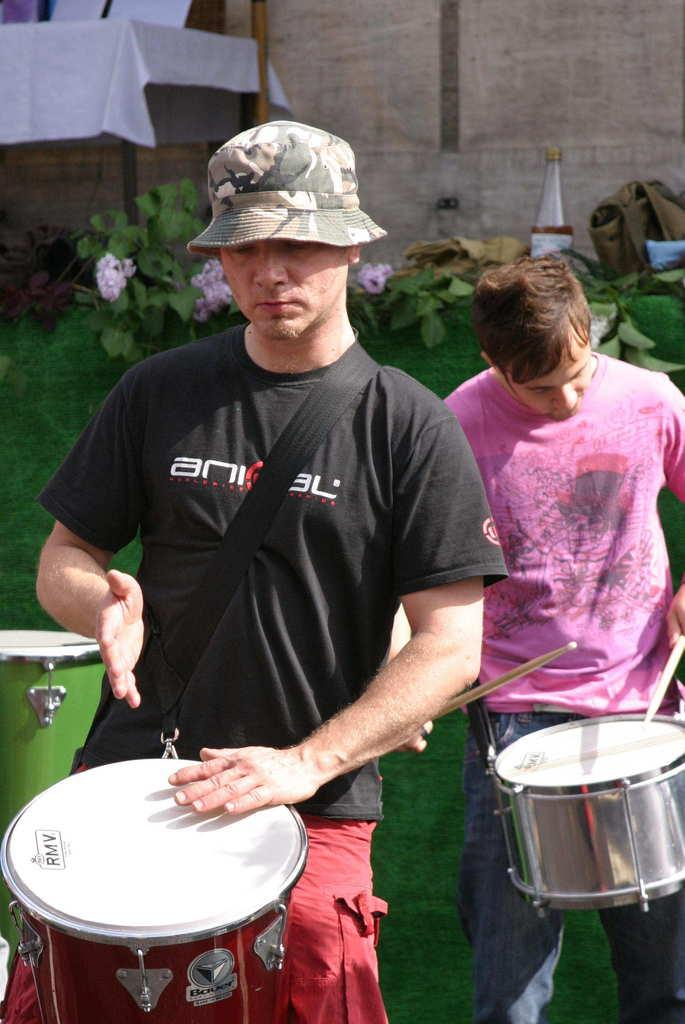How many people are in the image? There are two men in the image. What are the men doing in the image? The men are playing drums. Can you describe any other objects in the image besides the drums? There is a bottle, a table, and a house plant in the image. What type of error message is displayed on the screen in the image? There is no screen or error message present in the image. What kind of pump is used to water the house plant in the image? There is: There is no pump visible in the image; the house plant is not being watered. 